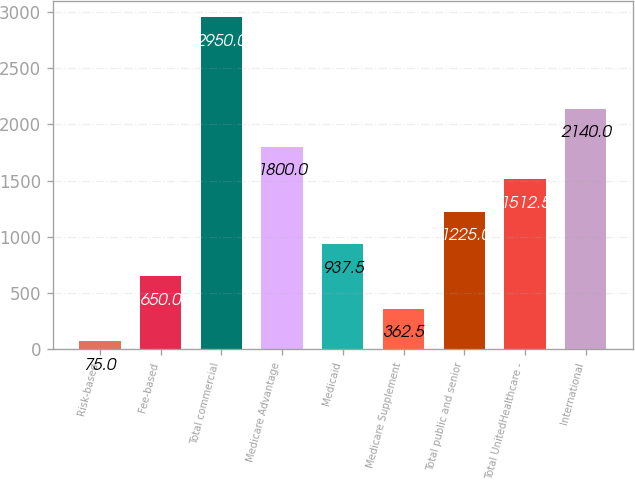Convert chart to OTSL. <chart><loc_0><loc_0><loc_500><loc_500><bar_chart><fcel>Risk-based<fcel>Fee-based<fcel>Total commercial<fcel>Medicare Advantage<fcel>Medicaid<fcel>Medicare Supplement<fcel>Total public and senior<fcel>Total UnitedHealthcare -<fcel>International<nl><fcel>75<fcel>650<fcel>2950<fcel>1800<fcel>937.5<fcel>362.5<fcel>1225<fcel>1512.5<fcel>2140<nl></chart> 